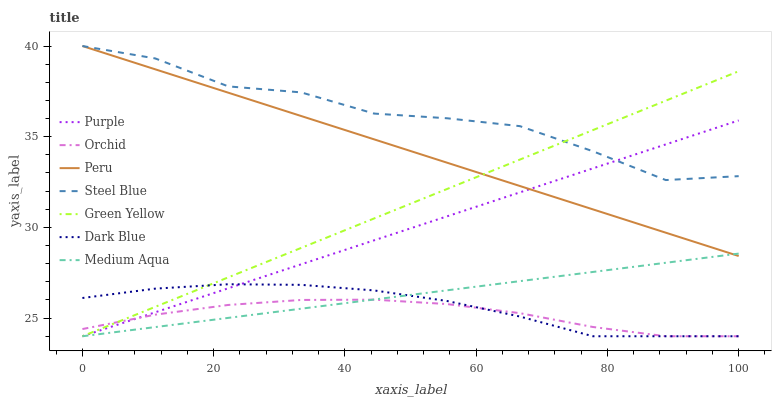Does Dark Blue have the minimum area under the curve?
Answer yes or no. No. Does Dark Blue have the maximum area under the curve?
Answer yes or no. No. Is Dark Blue the smoothest?
Answer yes or no. No. Is Dark Blue the roughest?
Answer yes or no. No. Does Steel Blue have the lowest value?
Answer yes or no. No. Does Dark Blue have the highest value?
Answer yes or no. No. Is Orchid less than Steel Blue?
Answer yes or no. Yes. Is Peru greater than Orchid?
Answer yes or no. Yes. Does Orchid intersect Steel Blue?
Answer yes or no. No. 